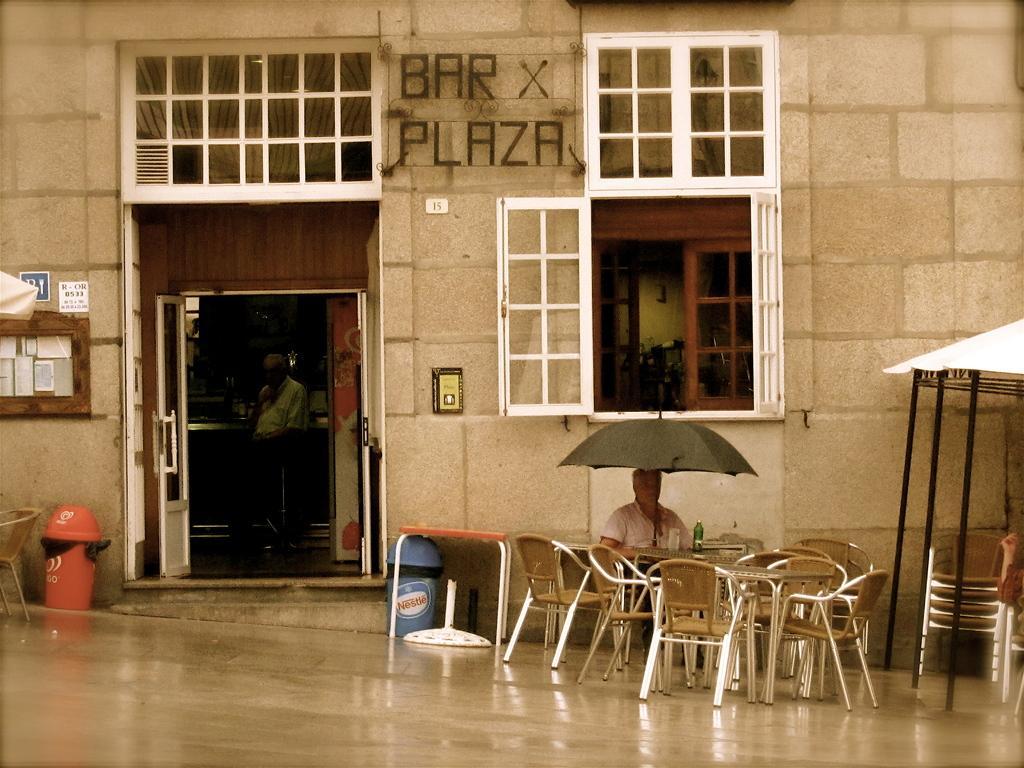Please provide a concise description of this image. A man is sitting in a chair at a table holding an umbrella upon him. There is building titles "brax plaza". There is a door and window. 